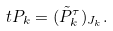<formula> <loc_0><loc_0><loc_500><loc_500>\ t P _ { k } = ( \tilde { P } _ { k } ^ { \tau } ) _ { J _ { k } } .</formula> 